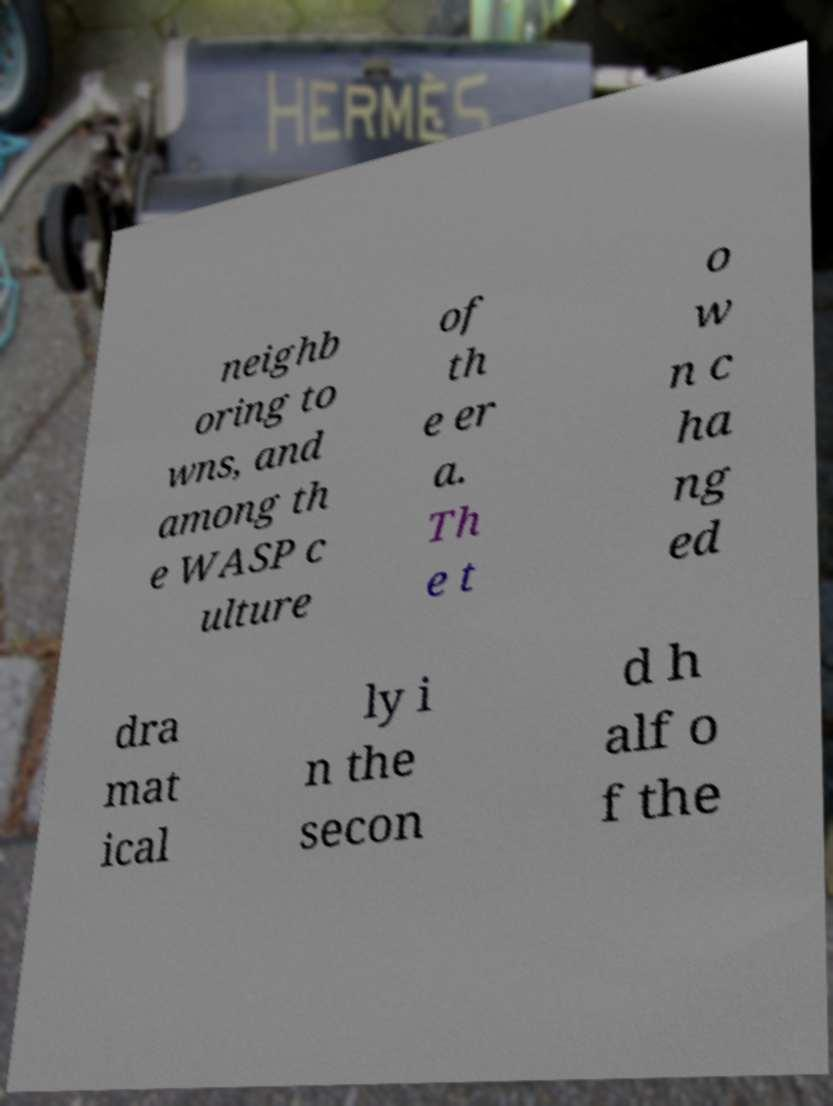There's text embedded in this image that I need extracted. Can you transcribe it verbatim? neighb oring to wns, and among th e WASP c ulture of th e er a. Th e t o w n c ha ng ed dra mat ical ly i n the secon d h alf o f the 